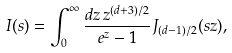<formula> <loc_0><loc_0><loc_500><loc_500>I ( s ) = \int _ { 0 } ^ { \infty } { \frac { d z \, z ^ { ( d + 3 ) / 2 } } { e ^ { z } - 1 } } J _ { ( d - 1 ) / 2 } ( s z ) ,</formula> 